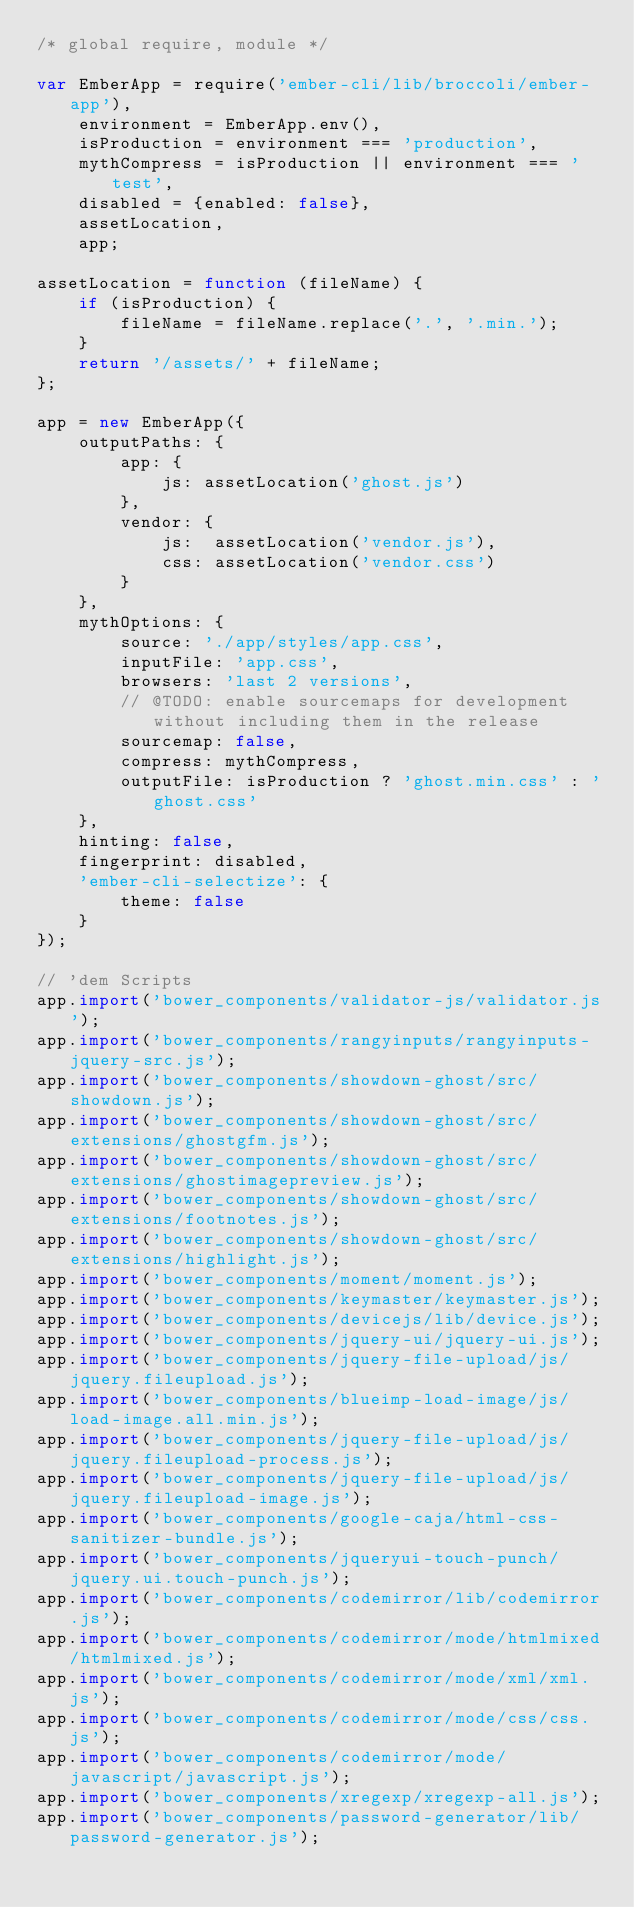Convert code to text. <code><loc_0><loc_0><loc_500><loc_500><_JavaScript_>/* global require, module */

var EmberApp = require('ember-cli/lib/broccoli/ember-app'),
    environment = EmberApp.env(),
    isProduction = environment === 'production',
    mythCompress = isProduction || environment === 'test',
    disabled = {enabled: false},
    assetLocation,
    app;

assetLocation = function (fileName) {
    if (isProduction) {
        fileName = fileName.replace('.', '.min.');
    }
    return '/assets/' + fileName;
};

app = new EmberApp({
    outputPaths: {
        app: {
            js: assetLocation('ghost.js')
        },
        vendor: {
            js:  assetLocation('vendor.js'),
            css: assetLocation('vendor.css')
        }
    },
    mythOptions: {
        source: './app/styles/app.css',
        inputFile: 'app.css',
        browsers: 'last 2 versions',
        // @TODO: enable sourcemaps for development without including them in the release
        sourcemap: false,
        compress: mythCompress,
        outputFile: isProduction ? 'ghost.min.css' : 'ghost.css'
    },
    hinting: false,
    fingerprint: disabled,
    'ember-cli-selectize': {
        theme: false
    }
});

// 'dem Scripts
app.import('bower_components/validator-js/validator.js');
app.import('bower_components/rangyinputs/rangyinputs-jquery-src.js');
app.import('bower_components/showdown-ghost/src/showdown.js');
app.import('bower_components/showdown-ghost/src/extensions/ghostgfm.js');
app.import('bower_components/showdown-ghost/src/extensions/ghostimagepreview.js');
app.import('bower_components/showdown-ghost/src/extensions/footnotes.js');
app.import('bower_components/showdown-ghost/src/extensions/highlight.js');
app.import('bower_components/moment/moment.js');
app.import('bower_components/keymaster/keymaster.js');
app.import('bower_components/devicejs/lib/device.js');
app.import('bower_components/jquery-ui/jquery-ui.js');
app.import('bower_components/jquery-file-upload/js/jquery.fileupload.js');
app.import('bower_components/blueimp-load-image/js/load-image.all.min.js');
app.import('bower_components/jquery-file-upload/js/jquery.fileupload-process.js');
app.import('bower_components/jquery-file-upload/js/jquery.fileupload-image.js');
app.import('bower_components/google-caja/html-css-sanitizer-bundle.js');
app.import('bower_components/jqueryui-touch-punch/jquery.ui.touch-punch.js');
app.import('bower_components/codemirror/lib/codemirror.js');
app.import('bower_components/codemirror/mode/htmlmixed/htmlmixed.js');
app.import('bower_components/codemirror/mode/xml/xml.js');
app.import('bower_components/codemirror/mode/css/css.js');
app.import('bower_components/codemirror/mode/javascript/javascript.js');
app.import('bower_components/xregexp/xregexp-all.js');
app.import('bower_components/password-generator/lib/password-generator.js');</code> 